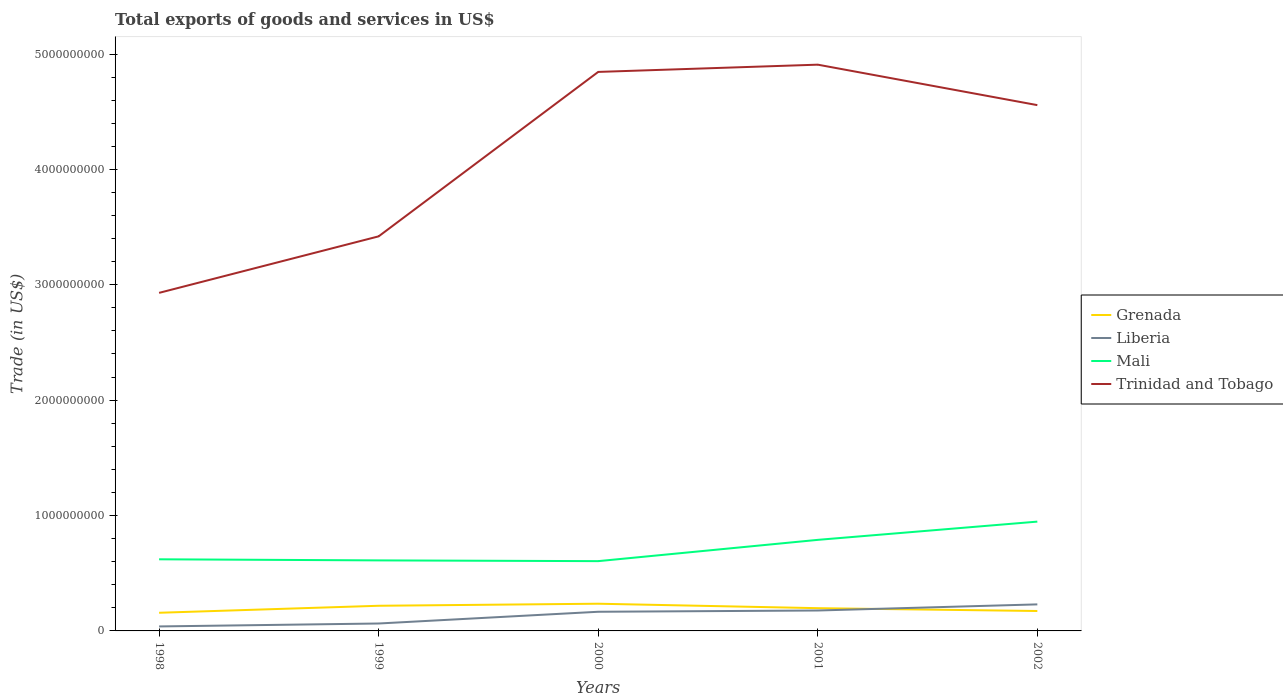How many different coloured lines are there?
Make the answer very short. 4. Does the line corresponding to Trinidad and Tobago intersect with the line corresponding to Grenada?
Your response must be concise. No. Across all years, what is the maximum total exports of goods and services in Mali?
Your response must be concise. 6.05e+08. In which year was the total exports of goods and services in Trinidad and Tobago maximum?
Provide a succinct answer. 1998. What is the total total exports of goods and services in Mali in the graph?
Your answer should be very brief. 6.53e+06. What is the difference between the highest and the second highest total exports of goods and services in Liberia?
Offer a terse response. 1.91e+08. Is the total exports of goods and services in Liberia strictly greater than the total exports of goods and services in Grenada over the years?
Offer a very short reply. No. How many lines are there?
Provide a succinct answer. 4. Does the graph contain any zero values?
Your answer should be compact. No. Does the graph contain grids?
Keep it short and to the point. No. Where does the legend appear in the graph?
Ensure brevity in your answer.  Center right. How are the legend labels stacked?
Make the answer very short. Vertical. What is the title of the graph?
Offer a terse response. Total exports of goods and services in US$. What is the label or title of the Y-axis?
Offer a terse response. Trade (in US$). What is the Trade (in US$) in Grenada in 1998?
Make the answer very short. 1.57e+08. What is the Trade (in US$) in Liberia in 1998?
Keep it short and to the point. 3.88e+07. What is the Trade (in US$) of Mali in 1998?
Offer a very short reply. 6.21e+08. What is the Trade (in US$) of Trinidad and Tobago in 1998?
Give a very brief answer. 2.93e+09. What is the Trade (in US$) in Grenada in 1999?
Make the answer very short. 2.18e+08. What is the Trade (in US$) in Liberia in 1999?
Your answer should be compact. 6.43e+07. What is the Trade (in US$) in Mali in 1999?
Your answer should be compact. 6.11e+08. What is the Trade (in US$) in Trinidad and Tobago in 1999?
Offer a very short reply. 3.42e+09. What is the Trade (in US$) of Grenada in 2000?
Provide a succinct answer. 2.36e+08. What is the Trade (in US$) in Liberia in 2000?
Your answer should be compact. 1.66e+08. What is the Trade (in US$) in Mali in 2000?
Your answer should be very brief. 6.05e+08. What is the Trade (in US$) in Trinidad and Tobago in 2000?
Keep it short and to the point. 4.84e+09. What is the Trade (in US$) in Grenada in 2001?
Offer a very short reply. 1.97e+08. What is the Trade (in US$) in Liberia in 2001?
Keep it short and to the point. 1.77e+08. What is the Trade (in US$) of Mali in 2001?
Your answer should be compact. 7.89e+08. What is the Trade (in US$) in Trinidad and Tobago in 2001?
Your answer should be very brief. 4.91e+09. What is the Trade (in US$) in Grenada in 2002?
Provide a short and direct response. 1.73e+08. What is the Trade (in US$) in Liberia in 2002?
Provide a short and direct response. 2.30e+08. What is the Trade (in US$) of Mali in 2002?
Offer a terse response. 9.47e+08. What is the Trade (in US$) of Trinidad and Tobago in 2002?
Ensure brevity in your answer.  4.56e+09. Across all years, what is the maximum Trade (in US$) in Grenada?
Give a very brief answer. 2.36e+08. Across all years, what is the maximum Trade (in US$) of Liberia?
Make the answer very short. 2.30e+08. Across all years, what is the maximum Trade (in US$) in Mali?
Offer a very short reply. 9.47e+08. Across all years, what is the maximum Trade (in US$) in Trinidad and Tobago?
Make the answer very short. 4.91e+09. Across all years, what is the minimum Trade (in US$) of Grenada?
Provide a short and direct response. 1.57e+08. Across all years, what is the minimum Trade (in US$) of Liberia?
Your response must be concise. 3.88e+07. Across all years, what is the minimum Trade (in US$) of Mali?
Offer a terse response. 6.05e+08. Across all years, what is the minimum Trade (in US$) of Trinidad and Tobago?
Keep it short and to the point. 2.93e+09. What is the total Trade (in US$) in Grenada in the graph?
Give a very brief answer. 9.81e+08. What is the total Trade (in US$) in Liberia in the graph?
Offer a very short reply. 6.76e+08. What is the total Trade (in US$) of Mali in the graph?
Ensure brevity in your answer.  3.57e+09. What is the total Trade (in US$) in Trinidad and Tobago in the graph?
Ensure brevity in your answer.  2.07e+1. What is the difference between the Trade (in US$) in Grenada in 1998 and that in 1999?
Ensure brevity in your answer.  -6.06e+07. What is the difference between the Trade (in US$) in Liberia in 1998 and that in 1999?
Provide a short and direct response. -2.55e+07. What is the difference between the Trade (in US$) in Mali in 1998 and that in 1999?
Make the answer very short. 9.38e+06. What is the difference between the Trade (in US$) of Trinidad and Tobago in 1998 and that in 1999?
Provide a succinct answer. -4.90e+08. What is the difference between the Trade (in US$) of Grenada in 1998 and that in 2000?
Your answer should be very brief. -7.83e+07. What is the difference between the Trade (in US$) of Liberia in 1998 and that in 2000?
Ensure brevity in your answer.  -1.27e+08. What is the difference between the Trade (in US$) in Mali in 1998 and that in 2000?
Your response must be concise. 1.59e+07. What is the difference between the Trade (in US$) of Trinidad and Tobago in 1998 and that in 2000?
Offer a very short reply. -1.91e+09. What is the difference between the Trade (in US$) in Grenada in 1998 and that in 2001?
Offer a very short reply. -3.97e+07. What is the difference between the Trade (in US$) in Liberia in 1998 and that in 2001?
Your answer should be compact. -1.38e+08. What is the difference between the Trade (in US$) in Mali in 1998 and that in 2001?
Your response must be concise. -1.69e+08. What is the difference between the Trade (in US$) in Trinidad and Tobago in 1998 and that in 2001?
Your answer should be compact. -1.98e+09. What is the difference between the Trade (in US$) of Grenada in 1998 and that in 2002?
Your response must be concise. -1.52e+07. What is the difference between the Trade (in US$) of Liberia in 1998 and that in 2002?
Provide a succinct answer. -1.91e+08. What is the difference between the Trade (in US$) of Mali in 1998 and that in 2002?
Keep it short and to the point. -3.27e+08. What is the difference between the Trade (in US$) in Trinidad and Tobago in 1998 and that in 2002?
Offer a very short reply. -1.63e+09. What is the difference between the Trade (in US$) in Grenada in 1999 and that in 2000?
Your answer should be very brief. -1.77e+07. What is the difference between the Trade (in US$) in Liberia in 1999 and that in 2000?
Provide a short and direct response. -1.02e+08. What is the difference between the Trade (in US$) in Mali in 1999 and that in 2000?
Make the answer very short. 6.53e+06. What is the difference between the Trade (in US$) of Trinidad and Tobago in 1999 and that in 2000?
Offer a very short reply. -1.43e+09. What is the difference between the Trade (in US$) in Grenada in 1999 and that in 2001?
Give a very brief answer. 2.09e+07. What is the difference between the Trade (in US$) of Liberia in 1999 and that in 2001?
Make the answer very short. -1.13e+08. What is the difference between the Trade (in US$) of Mali in 1999 and that in 2001?
Your response must be concise. -1.78e+08. What is the difference between the Trade (in US$) in Trinidad and Tobago in 1999 and that in 2001?
Give a very brief answer. -1.49e+09. What is the difference between the Trade (in US$) of Grenada in 1999 and that in 2002?
Give a very brief answer. 4.54e+07. What is the difference between the Trade (in US$) of Liberia in 1999 and that in 2002?
Make the answer very short. -1.66e+08. What is the difference between the Trade (in US$) of Mali in 1999 and that in 2002?
Your response must be concise. -3.36e+08. What is the difference between the Trade (in US$) in Trinidad and Tobago in 1999 and that in 2002?
Keep it short and to the point. -1.14e+09. What is the difference between the Trade (in US$) in Grenada in 2000 and that in 2001?
Offer a terse response. 3.86e+07. What is the difference between the Trade (in US$) in Liberia in 2000 and that in 2001?
Provide a succinct answer. -1.10e+07. What is the difference between the Trade (in US$) of Mali in 2000 and that in 2001?
Provide a short and direct response. -1.84e+08. What is the difference between the Trade (in US$) of Trinidad and Tobago in 2000 and that in 2001?
Ensure brevity in your answer.  -6.28e+07. What is the difference between the Trade (in US$) in Grenada in 2000 and that in 2002?
Provide a succinct answer. 6.31e+07. What is the difference between the Trade (in US$) in Liberia in 2000 and that in 2002?
Your answer should be compact. -6.40e+07. What is the difference between the Trade (in US$) of Mali in 2000 and that in 2002?
Your response must be concise. -3.43e+08. What is the difference between the Trade (in US$) of Trinidad and Tobago in 2000 and that in 2002?
Keep it short and to the point. 2.88e+08. What is the difference between the Trade (in US$) of Grenada in 2001 and that in 2002?
Make the answer very short. 2.45e+07. What is the difference between the Trade (in US$) in Liberia in 2001 and that in 2002?
Your answer should be compact. -5.30e+07. What is the difference between the Trade (in US$) in Mali in 2001 and that in 2002?
Give a very brief answer. -1.58e+08. What is the difference between the Trade (in US$) in Trinidad and Tobago in 2001 and that in 2002?
Your response must be concise. 3.51e+08. What is the difference between the Trade (in US$) of Grenada in 1998 and the Trade (in US$) of Liberia in 1999?
Give a very brief answer. 9.31e+07. What is the difference between the Trade (in US$) in Grenada in 1998 and the Trade (in US$) in Mali in 1999?
Provide a succinct answer. -4.54e+08. What is the difference between the Trade (in US$) in Grenada in 1998 and the Trade (in US$) in Trinidad and Tobago in 1999?
Provide a short and direct response. -3.26e+09. What is the difference between the Trade (in US$) of Liberia in 1998 and the Trade (in US$) of Mali in 1999?
Your answer should be very brief. -5.73e+08. What is the difference between the Trade (in US$) of Liberia in 1998 and the Trade (in US$) of Trinidad and Tobago in 1999?
Offer a terse response. -3.38e+09. What is the difference between the Trade (in US$) of Mali in 1998 and the Trade (in US$) of Trinidad and Tobago in 1999?
Your response must be concise. -2.80e+09. What is the difference between the Trade (in US$) in Grenada in 1998 and the Trade (in US$) in Liberia in 2000?
Offer a very short reply. -8.59e+06. What is the difference between the Trade (in US$) of Grenada in 1998 and the Trade (in US$) of Mali in 2000?
Your response must be concise. -4.47e+08. What is the difference between the Trade (in US$) in Grenada in 1998 and the Trade (in US$) in Trinidad and Tobago in 2000?
Make the answer very short. -4.69e+09. What is the difference between the Trade (in US$) in Liberia in 1998 and the Trade (in US$) in Mali in 2000?
Ensure brevity in your answer.  -5.66e+08. What is the difference between the Trade (in US$) of Liberia in 1998 and the Trade (in US$) of Trinidad and Tobago in 2000?
Your answer should be compact. -4.81e+09. What is the difference between the Trade (in US$) in Mali in 1998 and the Trade (in US$) in Trinidad and Tobago in 2000?
Your answer should be compact. -4.22e+09. What is the difference between the Trade (in US$) in Grenada in 1998 and the Trade (in US$) in Liberia in 2001?
Give a very brief answer. -1.96e+07. What is the difference between the Trade (in US$) of Grenada in 1998 and the Trade (in US$) of Mali in 2001?
Your answer should be compact. -6.32e+08. What is the difference between the Trade (in US$) in Grenada in 1998 and the Trade (in US$) in Trinidad and Tobago in 2001?
Ensure brevity in your answer.  -4.75e+09. What is the difference between the Trade (in US$) of Liberia in 1998 and the Trade (in US$) of Mali in 2001?
Your answer should be compact. -7.50e+08. What is the difference between the Trade (in US$) of Liberia in 1998 and the Trade (in US$) of Trinidad and Tobago in 2001?
Offer a terse response. -4.87e+09. What is the difference between the Trade (in US$) in Mali in 1998 and the Trade (in US$) in Trinidad and Tobago in 2001?
Ensure brevity in your answer.  -4.29e+09. What is the difference between the Trade (in US$) in Grenada in 1998 and the Trade (in US$) in Liberia in 2002?
Give a very brief answer. -7.26e+07. What is the difference between the Trade (in US$) of Grenada in 1998 and the Trade (in US$) of Mali in 2002?
Offer a terse response. -7.90e+08. What is the difference between the Trade (in US$) of Grenada in 1998 and the Trade (in US$) of Trinidad and Tobago in 2002?
Your answer should be very brief. -4.40e+09. What is the difference between the Trade (in US$) in Liberia in 1998 and the Trade (in US$) in Mali in 2002?
Give a very brief answer. -9.08e+08. What is the difference between the Trade (in US$) in Liberia in 1998 and the Trade (in US$) in Trinidad and Tobago in 2002?
Offer a terse response. -4.52e+09. What is the difference between the Trade (in US$) in Mali in 1998 and the Trade (in US$) in Trinidad and Tobago in 2002?
Make the answer very short. -3.94e+09. What is the difference between the Trade (in US$) in Grenada in 1999 and the Trade (in US$) in Liberia in 2000?
Offer a terse response. 5.20e+07. What is the difference between the Trade (in US$) in Grenada in 1999 and the Trade (in US$) in Mali in 2000?
Give a very brief answer. -3.87e+08. What is the difference between the Trade (in US$) of Grenada in 1999 and the Trade (in US$) of Trinidad and Tobago in 2000?
Offer a terse response. -4.63e+09. What is the difference between the Trade (in US$) in Liberia in 1999 and the Trade (in US$) in Mali in 2000?
Offer a terse response. -5.40e+08. What is the difference between the Trade (in US$) in Liberia in 1999 and the Trade (in US$) in Trinidad and Tobago in 2000?
Make the answer very short. -4.78e+09. What is the difference between the Trade (in US$) of Mali in 1999 and the Trade (in US$) of Trinidad and Tobago in 2000?
Make the answer very short. -4.23e+09. What is the difference between the Trade (in US$) of Grenada in 1999 and the Trade (in US$) of Liberia in 2001?
Make the answer very short. 4.10e+07. What is the difference between the Trade (in US$) in Grenada in 1999 and the Trade (in US$) in Mali in 2001?
Your response must be concise. -5.71e+08. What is the difference between the Trade (in US$) of Grenada in 1999 and the Trade (in US$) of Trinidad and Tobago in 2001?
Offer a very short reply. -4.69e+09. What is the difference between the Trade (in US$) in Liberia in 1999 and the Trade (in US$) in Mali in 2001?
Provide a succinct answer. -7.25e+08. What is the difference between the Trade (in US$) of Liberia in 1999 and the Trade (in US$) of Trinidad and Tobago in 2001?
Your response must be concise. -4.84e+09. What is the difference between the Trade (in US$) of Mali in 1999 and the Trade (in US$) of Trinidad and Tobago in 2001?
Offer a terse response. -4.30e+09. What is the difference between the Trade (in US$) of Grenada in 1999 and the Trade (in US$) of Liberia in 2002?
Make the answer very short. -1.20e+07. What is the difference between the Trade (in US$) of Grenada in 1999 and the Trade (in US$) of Mali in 2002?
Give a very brief answer. -7.29e+08. What is the difference between the Trade (in US$) of Grenada in 1999 and the Trade (in US$) of Trinidad and Tobago in 2002?
Provide a short and direct response. -4.34e+09. What is the difference between the Trade (in US$) in Liberia in 1999 and the Trade (in US$) in Mali in 2002?
Your answer should be compact. -8.83e+08. What is the difference between the Trade (in US$) in Liberia in 1999 and the Trade (in US$) in Trinidad and Tobago in 2002?
Offer a terse response. -4.49e+09. What is the difference between the Trade (in US$) of Mali in 1999 and the Trade (in US$) of Trinidad and Tobago in 2002?
Keep it short and to the point. -3.95e+09. What is the difference between the Trade (in US$) in Grenada in 2000 and the Trade (in US$) in Liberia in 2001?
Provide a succinct answer. 5.87e+07. What is the difference between the Trade (in US$) in Grenada in 2000 and the Trade (in US$) in Mali in 2001?
Provide a short and direct response. -5.54e+08. What is the difference between the Trade (in US$) in Grenada in 2000 and the Trade (in US$) in Trinidad and Tobago in 2001?
Provide a short and direct response. -4.67e+09. What is the difference between the Trade (in US$) of Liberia in 2000 and the Trade (in US$) of Mali in 2001?
Offer a very short reply. -6.23e+08. What is the difference between the Trade (in US$) of Liberia in 2000 and the Trade (in US$) of Trinidad and Tobago in 2001?
Give a very brief answer. -4.74e+09. What is the difference between the Trade (in US$) in Mali in 2000 and the Trade (in US$) in Trinidad and Tobago in 2001?
Ensure brevity in your answer.  -4.30e+09. What is the difference between the Trade (in US$) of Grenada in 2000 and the Trade (in US$) of Liberia in 2002?
Your response must be concise. 5.73e+06. What is the difference between the Trade (in US$) of Grenada in 2000 and the Trade (in US$) of Mali in 2002?
Provide a succinct answer. -7.12e+08. What is the difference between the Trade (in US$) in Grenada in 2000 and the Trade (in US$) in Trinidad and Tobago in 2002?
Provide a succinct answer. -4.32e+09. What is the difference between the Trade (in US$) of Liberia in 2000 and the Trade (in US$) of Mali in 2002?
Provide a short and direct response. -7.81e+08. What is the difference between the Trade (in US$) of Liberia in 2000 and the Trade (in US$) of Trinidad and Tobago in 2002?
Offer a terse response. -4.39e+09. What is the difference between the Trade (in US$) of Mali in 2000 and the Trade (in US$) of Trinidad and Tobago in 2002?
Make the answer very short. -3.95e+09. What is the difference between the Trade (in US$) of Grenada in 2001 and the Trade (in US$) of Liberia in 2002?
Your answer should be compact. -3.29e+07. What is the difference between the Trade (in US$) in Grenada in 2001 and the Trade (in US$) in Mali in 2002?
Your answer should be very brief. -7.50e+08. What is the difference between the Trade (in US$) in Grenada in 2001 and the Trade (in US$) in Trinidad and Tobago in 2002?
Ensure brevity in your answer.  -4.36e+09. What is the difference between the Trade (in US$) in Liberia in 2001 and the Trade (in US$) in Mali in 2002?
Your answer should be compact. -7.70e+08. What is the difference between the Trade (in US$) of Liberia in 2001 and the Trade (in US$) of Trinidad and Tobago in 2002?
Provide a short and direct response. -4.38e+09. What is the difference between the Trade (in US$) in Mali in 2001 and the Trade (in US$) in Trinidad and Tobago in 2002?
Your response must be concise. -3.77e+09. What is the average Trade (in US$) of Grenada per year?
Offer a terse response. 1.96e+08. What is the average Trade (in US$) of Liberia per year?
Offer a very short reply. 1.35e+08. What is the average Trade (in US$) of Mali per year?
Your response must be concise. 7.15e+08. What is the average Trade (in US$) of Trinidad and Tobago per year?
Offer a terse response. 4.13e+09. In the year 1998, what is the difference between the Trade (in US$) in Grenada and Trade (in US$) in Liberia?
Keep it short and to the point. 1.19e+08. In the year 1998, what is the difference between the Trade (in US$) of Grenada and Trade (in US$) of Mali?
Offer a terse response. -4.63e+08. In the year 1998, what is the difference between the Trade (in US$) of Grenada and Trade (in US$) of Trinidad and Tobago?
Ensure brevity in your answer.  -2.77e+09. In the year 1998, what is the difference between the Trade (in US$) of Liberia and Trade (in US$) of Mali?
Your answer should be compact. -5.82e+08. In the year 1998, what is the difference between the Trade (in US$) in Liberia and Trade (in US$) in Trinidad and Tobago?
Give a very brief answer. -2.89e+09. In the year 1998, what is the difference between the Trade (in US$) in Mali and Trade (in US$) in Trinidad and Tobago?
Give a very brief answer. -2.31e+09. In the year 1999, what is the difference between the Trade (in US$) in Grenada and Trade (in US$) in Liberia?
Your answer should be very brief. 1.54e+08. In the year 1999, what is the difference between the Trade (in US$) in Grenada and Trade (in US$) in Mali?
Give a very brief answer. -3.93e+08. In the year 1999, what is the difference between the Trade (in US$) in Grenada and Trade (in US$) in Trinidad and Tobago?
Your response must be concise. -3.20e+09. In the year 1999, what is the difference between the Trade (in US$) in Liberia and Trade (in US$) in Mali?
Provide a short and direct response. -5.47e+08. In the year 1999, what is the difference between the Trade (in US$) in Liberia and Trade (in US$) in Trinidad and Tobago?
Provide a short and direct response. -3.36e+09. In the year 1999, what is the difference between the Trade (in US$) of Mali and Trade (in US$) of Trinidad and Tobago?
Your answer should be very brief. -2.81e+09. In the year 2000, what is the difference between the Trade (in US$) of Grenada and Trade (in US$) of Liberia?
Offer a very short reply. 6.97e+07. In the year 2000, what is the difference between the Trade (in US$) of Grenada and Trade (in US$) of Mali?
Make the answer very short. -3.69e+08. In the year 2000, what is the difference between the Trade (in US$) in Grenada and Trade (in US$) in Trinidad and Tobago?
Make the answer very short. -4.61e+09. In the year 2000, what is the difference between the Trade (in US$) of Liberia and Trade (in US$) of Mali?
Ensure brevity in your answer.  -4.39e+08. In the year 2000, what is the difference between the Trade (in US$) in Liberia and Trade (in US$) in Trinidad and Tobago?
Give a very brief answer. -4.68e+09. In the year 2000, what is the difference between the Trade (in US$) of Mali and Trade (in US$) of Trinidad and Tobago?
Your response must be concise. -4.24e+09. In the year 2001, what is the difference between the Trade (in US$) in Grenada and Trade (in US$) in Liberia?
Your answer should be very brief. 2.01e+07. In the year 2001, what is the difference between the Trade (in US$) in Grenada and Trade (in US$) in Mali?
Ensure brevity in your answer.  -5.92e+08. In the year 2001, what is the difference between the Trade (in US$) in Grenada and Trade (in US$) in Trinidad and Tobago?
Keep it short and to the point. -4.71e+09. In the year 2001, what is the difference between the Trade (in US$) in Liberia and Trade (in US$) in Mali?
Your answer should be compact. -6.12e+08. In the year 2001, what is the difference between the Trade (in US$) of Liberia and Trade (in US$) of Trinidad and Tobago?
Offer a terse response. -4.73e+09. In the year 2001, what is the difference between the Trade (in US$) of Mali and Trade (in US$) of Trinidad and Tobago?
Provide a short and direct response. -4.12e+09. In the year 2002, what is the difference between the Trade (in US$) in Grenada and Trade (in US$) in Liberia?
Offer a very short reply. -5.74e+07. In the year 2002, what is the difference between the Trade (in US$) in Grenada and Trade (in US$) in Mali?
Offer a very short reply. -7.75e+08. In the year 2002, what is the difference between the Trade (in US$) in Grenada and Trade (in US$) in Trinidad and Tobago?
Offer a very short reply. -4.38e+09. In the year 2002, what is the difference between the Trade (in US$) of Liberia and Trade (in US$) of Mali?
Make the answer very short. -7.17e+08. In the year 2002, what is the difference between the Trade (in US$) in Liberia and Trade (in US$) in Trinidad and Tobago?
Your answer should be compact. -4.33e+09. In the year 2002, what is the difference between the Trade (in US$) of Mali and Trade (in US$) of Trinidad and Tobago?
Offer a very short reply. -3.61e+09. What is the ratio of the Trade (in US$) of Grenada in 1998 to that in 1999?
Give a very brief answer. 0.72. What is the ratio of the Trade (in US$) of Liberia in 1998 to that in 1999?
Give a very brief answer. 0.6. What is the ratio of the Trade (in US$) in Mali in 1998 to that in 1999?
Keep it short and to the point. 1.02. What is the ratio of the Trade (in US$) of Trinidad and Tobago in 1998 to that in 1999?
Your answer should be very brief. 0.86. What is the ratio of the Trade (in US$) of Grenada in 1998 to that in 2000?
Provide a short and direct response. 0.67. What is the ratio of the Trade (in US$) of Liberia in 1998 to that in 2000?
Offer a terse response. 0.23. What is the ratio of the Trade (in US$) in Mali in 1998 to that in 2000?
Give a very brief answer. 1.03. What is the ratio of the Trade (in US$) in Trinidad and Tobago in 1998 to that in 2000?
Your response must be concise. 0.6. What is the ratio of the Trade (in US$) of Grenada in 1998 to that in 2001?
Give a very brief answer. 0.8. What is the ratio of the Trade (in US$) of Liberia in 1998 to that in 2001?
Ensure brevity in your answer.  0.22. What is the ratio of the Trade (in US$) in Mali in 1998 to that in 2001?
Make the answer very short. 0.79. What is the ratio of the Trade (in US$) in Trinidad and Tobago in 1998 to that in 2001?
Make the answer very short. 0.6. What is the ratio of the Trade (in US$) in Grenada in 1998 to that in 2002?
Give a very brief answer. 0.91. What is the ratio of the Trade (in US$) in Liberia in 1998 to that in 2002?
Make the answer very short. 0.17. What is the ratio of the Trade (in US$) in Mali in 1998 to that in 2002?
Your answer should be compact. 0.66. What is the ratio of the Trade (in US$) in Trinidad and Tobago in 1998 to that in 2002?
Offer a terse response. 0.64. What is the ratio of the Trade (in US$) in Grenada in 1999 to that in 2000?
Give a very brief answer. 0.93. What is the ratio of the Trade (in US$) of Liberia in 1999 to that in 2000?
Your answer should be very brief. 0.39. What is the ratio of the Trade (in US$) in Mali in 1999 to that in 2000?
Your response must be concise. 1.01. What is the ratio of the Trade (in US$) of Trinidad and Tobago in 1999 to that in 2000?
Offer a terse response. 0.71. What is the ratio of the Trade (in US$) in Grenada in 1999 to that in 2001?
Keep it short and to the point. 1.11. What is the ratio of the Trade (in US$) in Liberia in 1999 to that in 2001?
Offer a terse response. 0.36. What is the ratio of the Trade (in US$) of Mali in 1999 to that in 2001?
Offer a terse response. 0.77. What is the ratio of the Trade (in US$) of Trinidad and Tobago in 1999 to that in 2001?
Your response must be concise. 0.7. What is the ratio of the Trade (in US$) of Grenada in 1999 to that in 2002?
Your answer should be compact. 1.26. What is the ratio of the Trade (in US$) of Liberia in 1999 to that in 2002?
Your answer should be very brief. 0.28. What is the ratio of the Trade (in US$) in Mali in 1999 to that in 2002?
Give a very brief answer. 0.65. What is the ratio of the Trade (in US$) in Trinidad and Tobago in 1999 to that in 2002?
Your answer should be compact. 0.75. What is the ratio of the Trade (in US$) in Grenada in 2000 to that in 2001?
Your response must be concise. 1.2. What is the ratio of the Trade (in US$) in Liberia in 2000 to that in 2001?
Give a very brief answer. 0.94. What is the ratio of the Trade (in US$) of Mali in 2000 to that in 2001?
Ensure brevity in your answer.  0.77. What is the ratio of the Trade (in US$) of Trinidad and Tobago in 2000 to that in 2001?
Offer a terse response. 0.99. What is the ratio of the Trade (in US$) in Grenada in 2000 to that in 2002?
Your answer should be very brief. 1.37. What is the ratio of the Trade (in US$) in Liberia in 2000 to that in 2002?
Offer a terse response. 0.72. What is the ratio of the Trade (in US$) in Mali in 2000 to that in 2002?
Provide a succinct answer. 0.64. What is the ratio of the Trade (in US$) of Trinidad and Tobago in 2000 to that in 2002?
Your answer should be compact. 1.06. What is the ratio of the Trade (in US$) in Grenada in 2001 to that in 2002?
Provide a short and direct response. 1.14. What is the ratio of the Trade (in US$) in Liberia in 2001 to that in 2002?
Make the answer very short. 0.77. What is the ratio of the Trade (in US$) of Mali in 2001 to that in 2002?
Your answer should be compact. 0.83. What is the ratio of the Trade (in US$) in Trinidad and Tobago in 2001 to that in 2002?
Provide a short and direct response. 1.08. What is the difference between the highest and the second highest Trade (in US$) in Grenada?
Offer a terse response. 1.77e+07. What is the difference between the highest and the second highest Trade (in US$) of Liberia?
Provide a succinct answer. 5.30e+07. What is the difference between the highest and the second highest Trade (in US$) of Mali?
Offer a very short reply. 1.58e+08. What is the difference between the highest and the second highest Trade (in US$) in Trinidad and Tobago?
Give a very brief answer. 6.28e+07. What is the difference between the highest and the lowest Trade (in US$) of Grenada?
Your response must be concise. 7.83e+07. What is the difference between the highest and the lowest Trade (in US$) of Liberia?
Your response must be concise. 1.91e+08. What is the difference between the highest and the lowest Trade (in US$) in Mali?
Give a very brief answer. 3.43e+08. What is the difference between the highest and the lowest Trade (in US$) of Trinidad and Tobago?
Your answer should be compact. 1.98e+09. 